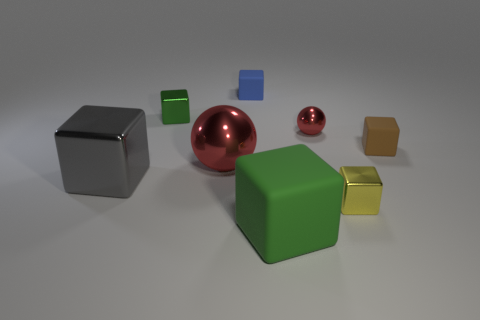Add 2 blue rubber objects. How many objects exist? 10 Subtract all blue blocks. How many blocks are left? 5 Subtract all brown rubber cubes. How many cubes are left? 5 Subtract 4 blocks. How many blocks are left? 2 Subtract all blue balls. Subtract all purple cylinders. How many balls are left? 2 Subtract all blue cylinders. How many yellow blocks are left? 1 Subtract all small red rubber blocks. Subtract all small yellow objects. How many objects are left? 7 Add 3 yellow shiny cubes. How many yellow shiny cubes are left? 4 Add 6 large cyan metallic cylinders. How many large cyan metallic cylinders exist? 6 Subtract 0 purple cylinders. How many objects are left? 8 